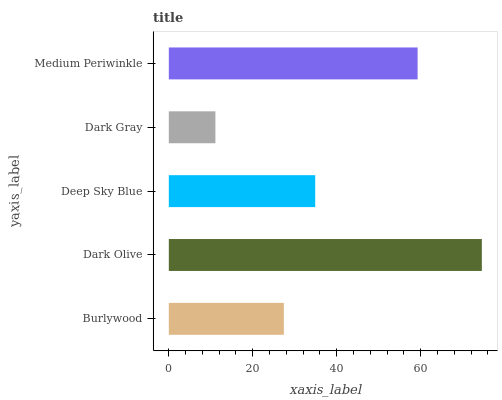Is Dark Gray the minimum?
Answer yes or no. Yes. Is Dark Olive the maximum?
Answer yes or no. Yes. Is Deep Sky Blue the minimum?
Answer yes or no. No. Is Deep Sky Blue the maximum?
Answer yes or no. No. Is Dark Olive greater than Deep Sky Blue?
Answer yes or no. Yes. Is Deep Sky Blue less than Dark Olive?
Answer yes or no. Yes. Is Deep Sky Blue greater than Dark Olive?
Answer yes or no. No. Is Dark Olive less than Deep Sky Blue?
Answer yes or no. No. Is Deep Sky Blue the high median?
Answer yes or no. Yes. Is Deep Sky Blue the low median?
Answer yes or no. Yes. Is Dark Olive the high median?
Answer yes or no. No. Is Dark Gray the low median?
Answer yes or no. No. 